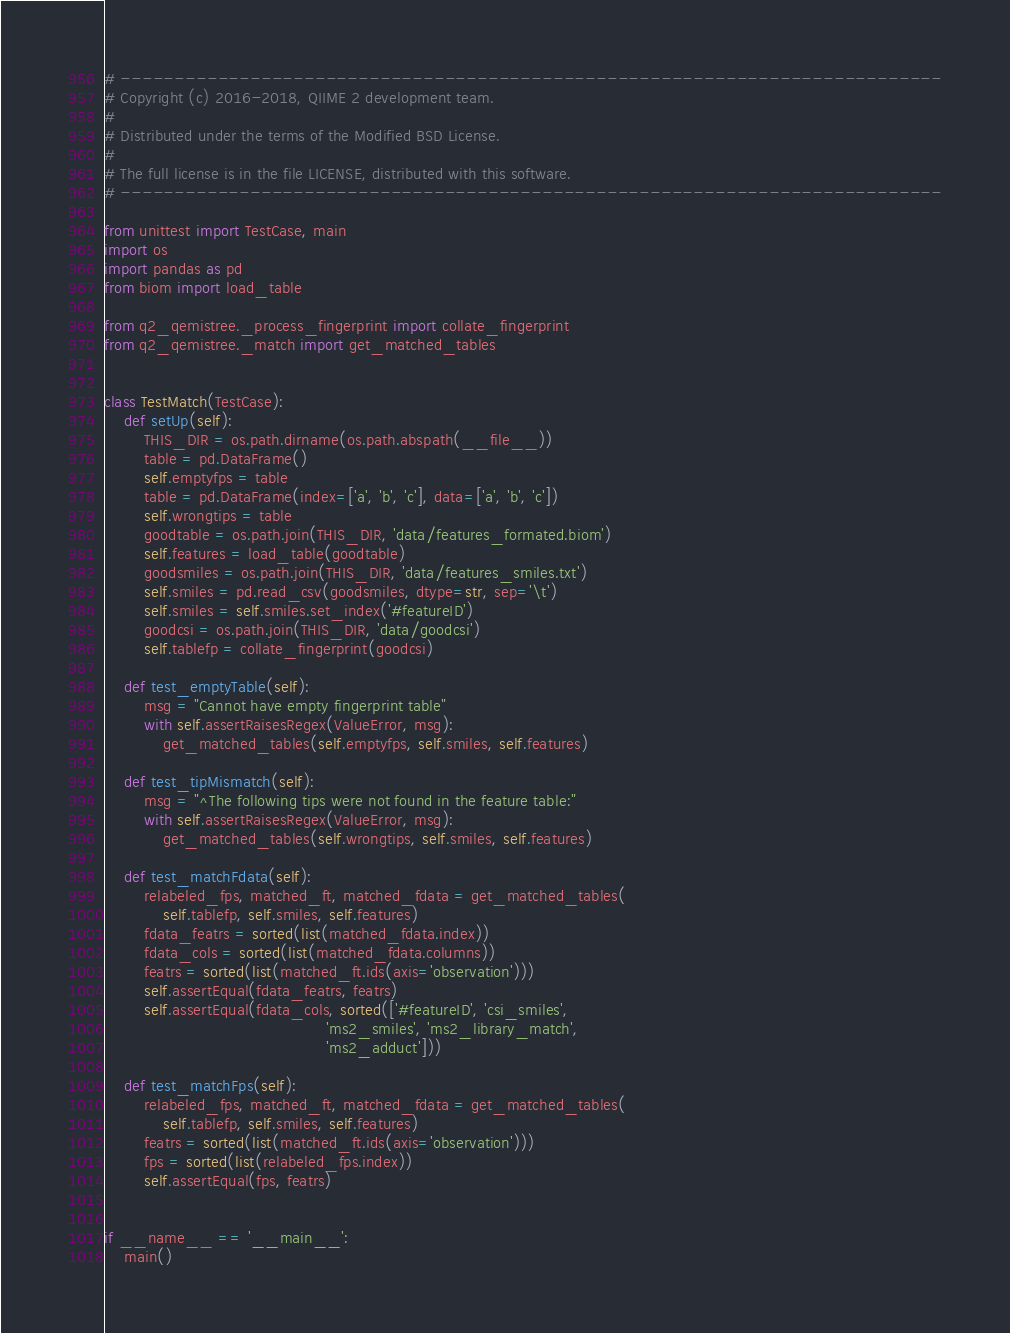Convert code to text. <code><loc_0><loc_0><loc_500><loc_500><_Python_># ----------------------------------------------------------------------------
# Copyright (c) 2016-2018, QIIME 2 development team.
#
# Distributed under the terms of the Modified BSD License.
#
# The full license is in the file LICENSE, distributed with this software.
# ----------------------------------------------------------------------------

from unittest import TestCase, main
import os
import pandas as pd
from biom import load_table

from q2_qemistree._process_fingerprint import collate_fingerprint
from q2_qemistree._match import get_matched_tables


class TestMatch(TestCase):
    def setUp(self):
        THIS_DIR = os.path.dirname(os.path.abspath(__file__))
        table = pd.DataFrame()
        self.emptyfps = table
        table = pd.DataFrame(index=['a', 'b', 'c'], data=['a', 'b', 'c'])
        self.wrongtips = table
        goodtable = os.path.join(THIS_DIR, 'data/features_formated.biom')
        self.features = load_table(goodtable)
        goodsmiles = os.path.join(THIS_DIR, 'data/features_smiles.txt')
        self.smiles = pd.read_csv(goodsmiles, dtype=str, sep='\t')
        self.smiles = self.smiles.set_index('#featureID')
        goodcsi = os.path.join(THIS_DIR, 'data/goodcsi')
        self.tablefp = collate_fingerprint(goodcsi)

    def test_emptyTable(self):
        msg = "Cannot have empty fingerprint table"
        with self.assertRaisesRegex(ValueError, msg):
            get_matched_tables(self.emptyfps, self.smiles, self.features)

    def test_tipMismatch(self):
        msg = "^The following tips were not found in the feature table:"
        with self.assertRaisesRegex(ValueError, msg):
            get_matched_tables(self.wrongtips, self.smiles, self.features)

    def test_matchFdata(self):
        relabeled_fps, matched_ft, matched_fdata = get_matched_tables(
            self.tablefp, self.smiles, self.features)
        fdata_featrs = sorted(list(matched_fdata.index))
        fdata_cols = sorted(list(matched_fdata.columns))
        featrs = sorted(list(matched_ft.ids(axis='observation')))
        self.assertEqual(fdata_featrs, featrs)
        self.assertEqual(fdata_cols, sorted(['#featureID', 'csi_smiles',
                                             'ms2_smiles', 'ms2_library_match',
                                             'ms2_adduct']))

    def test_matchFps(self):
        relabeled_fps, matched_ft, matched_fdata = get_matched_tables(
            self.tablefp, self.smiles, self.features)
        featrs = sorted(list(matched_ft.ids(axis='observation')))
        fps = sorted(list(relabeled_fps.index))
        self.assertEqual(fps, featrs)


if __name__ == '__main__':
    main()
</code> 